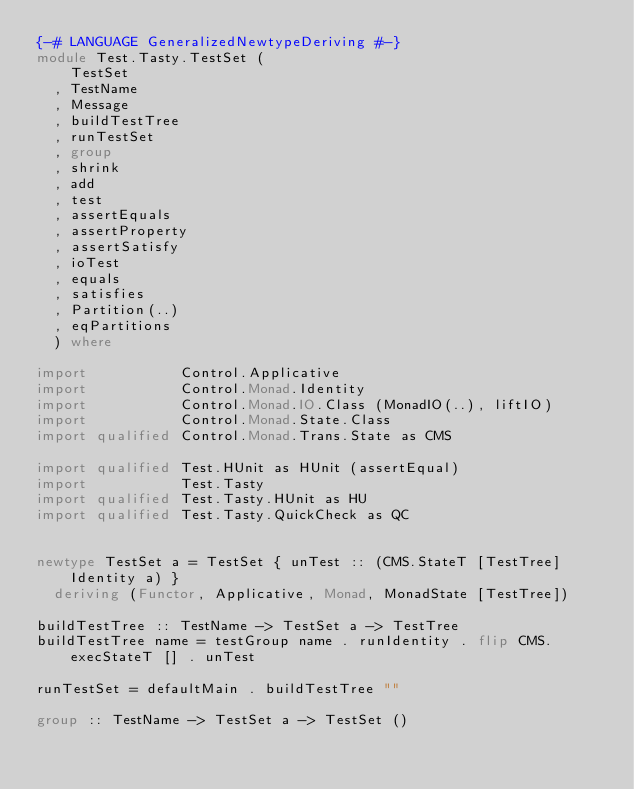Convert code to text. <code><loc_0><loc_0><loc_500><loc_500><_Haskell_>{-# LANGUAGE GeneralizedNewtypeDeriving #-}
module Test.Tasty.TestSet (
    TestSet
  , TestName
  , Message
  , buildTestTree
  , runTestSet
  , group
  , shrink
  , add
  , test
  , assertEquals
  , assertProperty
  , assertSatisfy
  , ioTest
  , equals
  , satisfies
  , Partition(..)
  , eqPartitions
  ) where

import           Control.Applicative
import           Control.Monad.Identity
import           Control.Monad.IO.Class (MonadIO(..), liftIO)
import           Control.Monad.State.Class
import qualified Control.Monad.Trans.State as CMS

import qualified Test.HUnit as HUnit (assertEqual)
import           Test.Tasty
import qualified Test.Tasty.HUnit as HU
import qualified Test.Tasty.QuickCheck as QC


newtype TestSet a = TestSet { unTest :: (CMS.StateT [TestTree] Identity a) }
  deriving (Functor, Applicative, Monad, MonadState [TestTree])

buildTestTree :: TestName -> TestSet a -> TestTree
buildTestTree name = testGroup name . runIdentity . flip CMS.execStateT [] . unTest

runTestSet = defaultMain . buildTestTree ""

group :: TestName -> TestSet a -> TestSet ()</code> 